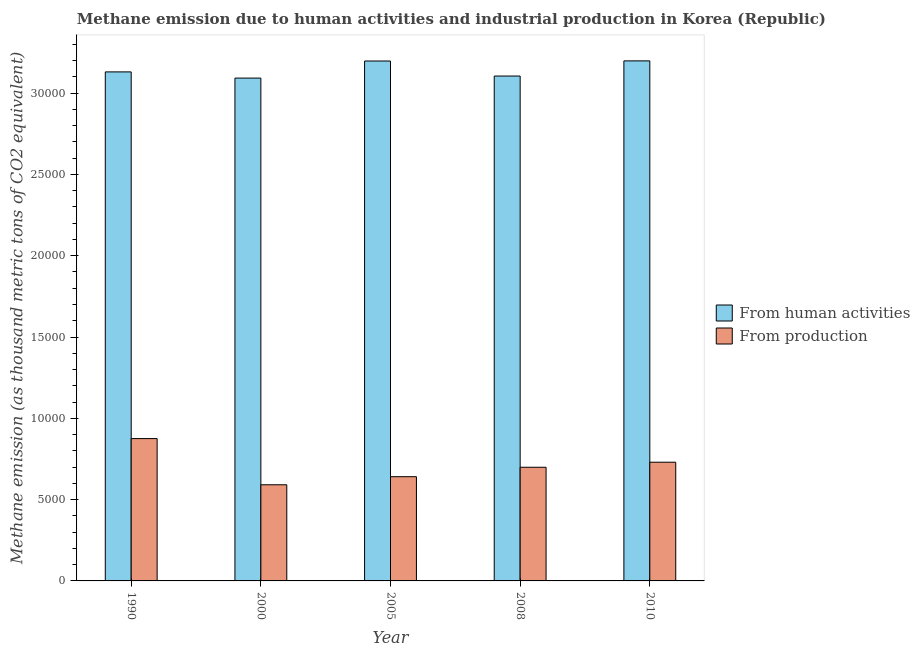How many different coloured bars are there?
Make the answer very short. 2. Are the number of bars on each tick of the X-axis equal?
Give a very brief answer. Yes. How many bars are there on the 1st tick from the left?
Give a very brief answer. 2. How many bars are there on the 3rd tick from the right?
Your answer should be very brief. 2. What is the label of the 5th group of bars from the left?
Offer a terse response. 2010. What is the amount of emissions generated from industries in 2010?
Your response must be concise. 7301.2. Across all years, what is the maximum amount of emissions from human activities?
Give a very brief answer. 3.20e+04. Across all years, what is the minimum amount of emissions from human activities?
Your answer should be compact. 3.09e+04. In which year was the amount of emissions generated from industries maximum?
Provide a short and direct response. 1990. What is the total amount of emissions generated from industries in the graph?
Make the answer very short. 3.54e+04. What is the difference between the amount of emissions generated from industries in 2000 and that in 2010?
Provide a short and direct response. -1388.4. What is the difference between the amount of emissions from human activities in 1990 and the amount of emissions generated from industries in 2005?
Give a very brief answer. -669.8. What is the average amount of emissions from human activities per year?
Your answer should be compact. 3.14e+04. In the year 2005, what is the difference between the amount of emissions generated from industries and amount of emissions from human activities?
Give a very brief answer. 0. What is the ratio of the amount of emissions from human activities in 1990 to that in 2000?
Provide a succinct answer. 1.01. What is the difference between the highest and the second highest amount of emissions generated from industries?
Give a very brief answer. 1453. What is the difference between the highest and the lowest amount of emissions from human activities?
Offer a terse response. 1058.8. In how many years, is the amount of emissions from human activities greater than the average amount of emissions from human activities taken over all years?
Your answer should be very brief. 2. What does the 1st bar from the left in 2010 represents?
Provide a short and direct response. From human activities. What does the 1st bar from the right in 2000 represents?
Your answer should be very brief. From production. Are all the bars in the graph horizontal?
Keep it short and to the point. No. How many years are there in the graph?
Provide a short and direct response. 5. Does the graph contain any zero values?
Ensure brevity in your answer.  No. How are the legend labels stacked?
Offer a very short reply. Vertical. What is the title of the graph?
Offer a terse response. Methane emission due to human activities and industrial production in Korea (Republic). Does "Taxes" appear as one of the legend labels in the graph?
Ensure brevity in your answer.  No. What is the label or title of the Y-axis?
Keep it short and to the point. Methane emission (as thousand metric tons of CO2 equivalent). What is the Methane emission (as thousand metric tons of CO2 equivalent) in From human activities in 1990?
Ensure brevity in your answer.  3.13e+04. What is the Methane emission (as thousand metric tons of CO2 equivalent) of From production in 1990?
Ensure brevity in your answer.  8754.2. What is the Methane emission (as thousand metric tons of CO2 equivalent) in From human activities in 2000?
Your response must be concise. 3.09e+04. What is the Methane emission (as thousand metric tons of CO2 equivalent) in From production in 2000?
Make the answer very short. 5912.8. What is the Methane emission (as thousand metric tons of CO2 equivalent) of From human activities in 2005?
Ensure brevity in your answer.  3.20e+04. What is the Methane emission (as thousand metric tons of CO2 equivalent) in From production in 2005?
Provide a succinct answer. 6410.4. What is the Methane emission (as thousand metric tons of CO2 equivalent) of From human activities in 2008?
Ensure brevity in your answer.  3.11e+04. What is the Methane emission (as thousand metric tons of CO2 equivalent) in From production in 2008?
Provide a short and direct response. 6990.7. What is the Methane emission (as thousand metric tons of CO2 equivalent) of From human activities in 2010?
Offer a very short reply. 3.20e+04. What is the Methane emission (as thousand metric tons of CO2 equivalent) in From production in 2010?
Your answer should be very brief. 7301.2. Across all years, what is the maximum Methane emission (as thousand metric tons of CO2 equivalent) of From human activities?
Your answer should be compact. 3.20e+04. Across all years, what is the maximum Methane emission (as thousand metric tons of CO2 equivalent) of From production?
Your response must be concise. 8754.2. Across all years, what is the minimum Methane emission (as thousand metric tons of CO2 equivalent) in From human activities?
Provide a short and direct response. 3.09e+04. Across all years, what is the minimum Methane emission (as thousand metric tons of CO2 equivalent) in From production?
Provide a short and direct response. 5912.8. What is the total Methane emission (as thousand metric tons of CO2 equivalent) of From human activities in the graph?
Your answer should be very brief. 1.57e+05. What is the total Methane emission (as thousand metric tons of CO2 equivalent) of From production in the graph?
Make the answer very short. 3.54e+04. What is the difference between the Methane emission (as thousand metric tons of CO2 equivalent) of From human activities in 1990 and that in 2000?
Your answer should be very brief. 381.1. What is the difference between the Methane emission (as thousand metric tons of CO2 equivalent) of From production in 1990 and that in 2000?
Your answer should be very brief. 2841.4. What is the difference between the Methane emission (as thousand metric tons of CO2 equivalent) in From human activities in 1990 and that in 2005?
Give a very brief answer. -669.8. What is the difference between the Methane emission (as thousand metric tons of CO2 equivalent) in From production in 1990 and that in 2005?
Provide a succinct answer. 2343.8. What is the difference between the Methane emission (as thousand metric tons of CO2 equivalent) of From human activities in 1990 and that in 2008?
Your answer should be very brief. 254.6. What is the difference between the Methane emission (as thousand metric tons of CO2 equivalent) in From production in 1990 and that in 2008?
Keep it short and to the point. 1763.5. What is the difference between the Methane emission (as thousand metric tons of CO2 equivalent) of From human activities in 1990 and that in 2010?
Give a very brief answer. -677.7. What is the difference between the Methane emission (as thousand metric tons of CO2 equivalent) of From production in 1990 and that in 2010?
Keep it short and to the point. 1453. What is the difference between the Methane emission (as thousand metric tons of CO2 equivalent) of From human activities in 2000 and that in 2005?
Your response must be concise. -1050.9. What is the difference between the Methane emission (as thousand metric tons of CO2 equivalent) in From production in 2000 and that in 2005?
Offer a terse response. -497.6. What is the difference between the Methane emission (as thousand metric tons of CO2 equivalent) of From human activities in 2000 and that in 2008?
Provide a short and direct response. -126.5. What is the difference between the Methane emission (as thousand metric tons of CO2 equivalent) of From production in 2000 and that in 2008?
Provide a short and direct response. -1077.9. What is the difference between the Methane emission (as thousand metric tons of CO2 equivalent) in From human activities in 2000 and that in 2010?
Keep it short and to the point. -1058.8. What is the difference between the Methane emission (as thousand metric tons of CO2 equivalent) in From production in 2000 and that in 2010?
Keep it short and to the point. -1388.4. What is the difference between the Methane emission (as thousand metric tons of CO2 equivalent) in From human activities in 2005 and that in 2008?
Your answer should be very brief. 924.4. What is the difference between the Methane emission (as thousand metric tons of CO2 equivalent) of From production in 2005 and that in 2008?
Provide a short and direct response. -580.3. What is the difference between the Methane emission (as thousand metric tons of CO2 equivalent) of From production in 2005 and that in 2010?
Your response must be concise. -890.8. What is the difference between the Methane emission (as thousand metric tons of CO2 equivalent) of From human activities in 2008 and that in 2010?
Keep it short and to the point. -932.3. What is the difference between the Methane emission (as thousand metric tons of CO2 equivalent) in From production in 2008 and that in 2010?
Your answer should be very brief. -310.5. What is the difference between the Methane emission (as thousand metric tons of CO2 equivalent) in From human activities in 1990 and the Methane emission (as thousand metric tons of CO2 equivalent) in From production in 2000?
Offer a terse response. 2.54e+04. What is the difference between the Methane emission (as thousand metric tons of CO2 equivalent) of From human activities in 1990 and the Methane emission (as thousand metric tons of CO2 equivalent) of From production in 2005?
Offer a very short reply. 2.49e+04. What is the difference between the Methane emission (as thousand metric tons of CO2 equivalent) of From human activities in 1990 and the Methane emission (as thousand metric tons of CO2 equivalent) of From production in 2008?
Provide a succinct answer. 2.43e+04. What is the difference between the Methane emission (as thousand metric tons of CO2 equivalent) of From human activities in 1990 and the Methane emission (as thousand metric tons of CO2 equivalent) of From production in 2010?
Ensure brevity in your answer.  2.40e+04. What is the difference between the Methane emission (as thousand metric tons of CO2 equivalent) in From human activities in 2000 and the Methane emission (as thousand metric tons of CO2 equivalent) in From production in 2005?
Provide a short and direct response. 2.45e+04. What is the difference between the Methane emission (as thousand metric tons of CO2 equivalent) of From human activities in 2000 and the Methane emission (as thousand metric tons of CO2 equivalent) of From production in 2008?
Ensure brevity in your answer.  2.39e+04. What is the difference between the Methane emission (as thousand metric tons of CO2 equivalent) of From human activities in 2000 and the Methane emission (as thousand metric tons of CO2 equivalent) of From production in 2010?
Keep it short and to the point. 2.36e+04. What is the difference between the Methane emission (as thousand metric tons of CO2 equivalent) in From human activities in 2005 and the Methane emission (as thousand metric tons of CO2 equivalent) in From production in 2008?
Provide a succinct answer. 2.50e+04. What is the difference between the Methane emission (as thousand metric tons of CO2 equivalent) in From human activities in 2005 and the Methane emission (as thousand metric tons of CO2 equivalent) in From production in 2010?
Your answer should be compact. 2.47e+04. What is the difference between the Methane emission (as thousand metric tons of CO2 equivalent) in From human activities in 2008 and the Methane emission (as thousand metric tons of CO2 equivalent) in From production in 2010?
Your response must be concise. 2.38e+04. What is the average Methane emission (as thousand metric tons of CO2 equivalent) in From human activities per year?
Provide a short and direct response. 3.14e+04. What is the average Methane emission (as thousand metric tons of CO2 equivalent) in From production per year?
Make the answer very short. 7073.86. In the year 1990, what is the difference between the Methane emission (as thousand metric tons of CO2 equivalent) in From human activities and Methane emission (as thousand metric tons of CO2 equivalent) in From production?
Offer a very short reply. 2.26e+04. In the year 2000, what is the difference between the Methane emission (as thousand metric tons of CO2 equivalent) of From human activities and Methane emission (as thousand metric tons of CO2 equivalent) of From production?
Ensure brevity in your answer.  2.50e+04. In the year 2005, what is the difference between the Methane emission (as thousand metric tons of CO2 equivalent) in From human activities and Methane emission (as thousand metric tons of CO2 equivalent) in From production?
Offer a terse response. 2.56e+04. In the year 2008, what is the difference between the Methane emission (as thousand metric tons of CO2 equivalent) in From human activities and Methane emission (as thousand metric tons of CO2 equivalent) in From production?
Keep it short and to the point. 2.41e+04. In the year 2010, what is the difference between the Methane emission (as thousand metric tons of CO2 equivalent) in From human activities and Methane emission (as thousand metric tons of CO2 equivalent) in From production?
Offer a terse response. 2.47e+04. What is the ratio of the Methane emission (as thousand metric tons of CO2 equivalent) in From human activities in 1990 to that in 2000?
Ensure brevity in your answer.  1.01. What is the ratio of the Methane emission (as thousand metric tons of CO2 equivalent) in From production in 1990 to that in 2000?
Give a very brief answer. 1.48. What is the ratio of the Methane emission (as thousand metric tons of CO2 equivalent) in From human activities in 1990 to that in 2005?
Your answer should be compact. 0.98. What is the ratio of the Methane emission (as thousand metric tons of CO2 equivalent) of From production in 1990 to that in 2005?
Give a very brief answer. 1.37. What is the ratio of the Methane emission (as thousand metric tons of CO2 equivalent) in From human activities in 1990 to that in 2008?
Provide a succinct answer. 1.01. What is the ratio of the Methane emission (as thousand metric tons of CO2 equivalent) in From production in 1990 to that in 2008?
Make the answer very short. 1.25. What is the ratio of the Methane emission (as thousand metric tons of CO2 equivalent) in From human activities in 1990 to that in 2010?
Offer a terse response. 0.98. What is the ratio of the Methane emission (as thousand metric tons of CO2 equivalent) in From production in 1990 to that in 2010?
Your response must be concise. 1.2. What is the ratio of the Methane emission (as thousand metric tons of CO2 equivalent) of From human activities in 2000 to that in 2005?
Provide a succinct answer. 0.97. What is the ratio of the Methane emission (as thousand metric tons of CO2 equivalent) in From production in 2000 to that in 2005?
Offer a very short reply. 0.92. What is the ratio of the Methane emission (as thousand metric tons of CO2 equivalent) of From human activities in 2000 to that in 2008?
Provide a short and direct response. 1. What is the ratio of the Methane emission (as thousand metric tons of CO2 equivalent) in From production in 2000 to that in 2008?
Ensure brevity in your answer.  0.85. What is the ratio of the Methane emission (as thousand metric tons of CO2 equivalent) in From human activities in 2000 to that in 2010?
Offer a terse response. 0.97. What is the ratio of the Methane emission (as thousand metric tons of CO2 equivalent) of From production in 2000 to that in 2010?
Your answer should be compact. 0.81. What is the ratio of the Methane emission (as thousand metric tons of CO2 equivalent) of From human activities in 2005 to that in 2008?
Your response must be concise. 1.03. What is the ratio of the Methane emission (as thousand metric tons of CO2 equivalent) in From production in 2005 to that in 2008?
Offer a very short reply. 0.92. What is the ratio of the Methane emission (as thousand metric tons of CO2 equivalent) in From production in 2005 to that in 2010?
Provide a succinct answer. 0.88. What is the ratio of the Methane emission (as thousand metric tons of CO2 equivalent) of From human activities in 2008 to that in 2010?
Offer a very short reply. 0.97. What is the ratio of the Methane emission (as thousand metric tons of CO2 equivalent) in From production in 2008 to that in 2010?
Your answer should be very brief. 0.96. What is the difference between the highest and the second highest Methane emission (as thousand metric tons of CO2 equivalent) in From human activities?
Your answer should be very brief. 7.9. What is the difference between the highest and the second highest Methane emission (as thousand metric tons of CO2 equivalent) in From production?
Your answer should be very brief. 1453. What is the difference between the highest and the lowest Methane emission (as thousand metric tons of CO2 equivalent) of From human activities?
Provide a succinct answer. 1058.8. What is the difference between the highest and the lowest Methane emission (as thousand metric tons of CO2 equivalent) in From production?
Ensure brevity in your answer.  2841.4. 